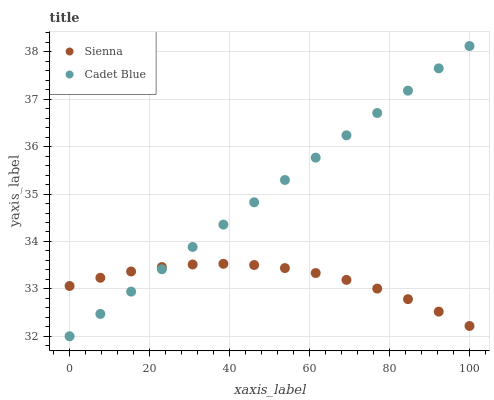Does Sienna have the minimum area under the curve?
Answer yes or no. Yes. Does Cadet Blue have the maximum area under the curve?
Answer yes or no. Yes. Does Cadet Blue have the minimum area under the curve?
Answer yes or no. No. Is Cadet Blue the smoothest?
Answer yes or no. Yes. Is Sienna the roughest?
Answer yes or no. Yes. Is Cadet Blue the roughest?
Answer yes or no. No. Does Cadet Blue have the lowest value?
Answer yes or no. Yes. Does Cadet Blue have the highest value?
Answer yes or no. Yes. Does Sienna intersect Cadet Blue?
Answer yes or no. Yes. Is Sienna less than Cadet Blue?
Answer yes or no. No. Is Sienna greater than Cadet Blue?
Answer yes or no. No. 